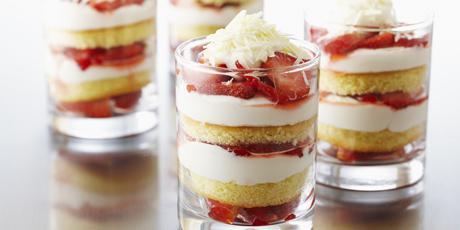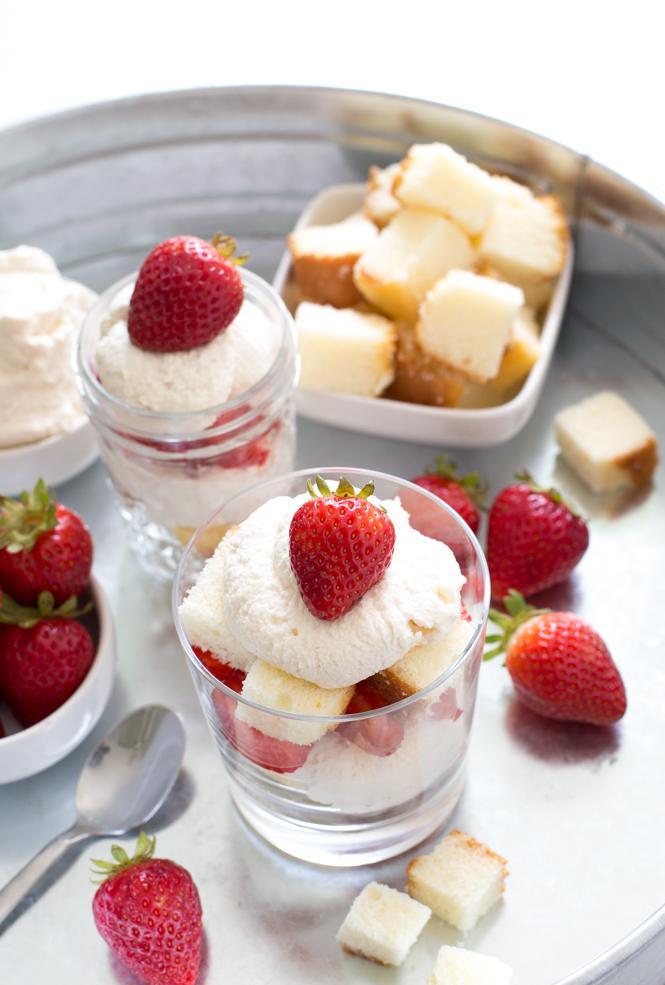The first image is the image on the left, the second image is the image on the right. Given the left and right images, does the statement "Each image is a display of at least three individual trifle desserts that are topped with pieces of whole fruit." hold true? Answer yes or no. No. The first image is the image on the left, the second image is the image on the right. For the images shown, is this caption "An image shows single-serve desserts garnished with blueberries and red raspberries." true? Answer yes or no. No. 